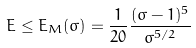Convert formula to latex. <formula><loc_0><loc_0><loc_500><loc_500>E \leq E _ { M } ( \sigma ) = \frac { 1 } { 2 0 } \frac { ( \sigma - 1 ) ^ { 5 } } { \sigma ^ { 5 / 2 } }</formula> 